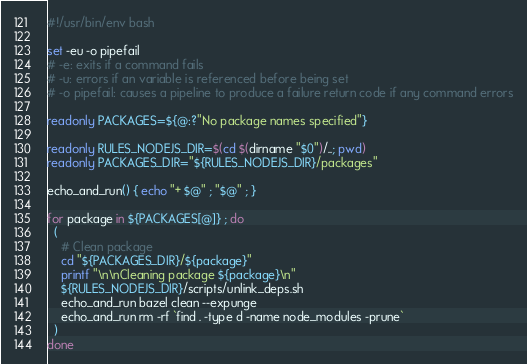<code> <loc_0><loc_0><loc_500><loc_500><_Bash_>#!/usr/bin/env bash

set -eu -o pipefail
# -e: exits if a command fails
# -u: errors if an variable is referenced before being set
# -o pipefail: causes a pipeline to produce a failure return code if any command errors

readonly PACKAGES=${@:?"No package names specified"}

readonly RULES_NODEJS_DIR=$(cd $(dirname "$0")/..; pwd)
readonly PACKAGES_DIR="${RULES_NODEJS_DIR}/packages"

echo_and_run() { echo "+ $@" ; "$@" ; }

for package in ${PACKAGES[@]} ; do
  (
    # Clean package
    cd "${PACKAGES_DIR}/${package}"
    printf "\n\nCleaning package ${package}\n"
    ${RULES_NODEJS_DIR}/scripts/unlink_deps.sh
    echo_and_run bazel clean --expunge
    echo_and_run rm -rf `find . -type d -name node_modules -prune`
  )
done
</code> 